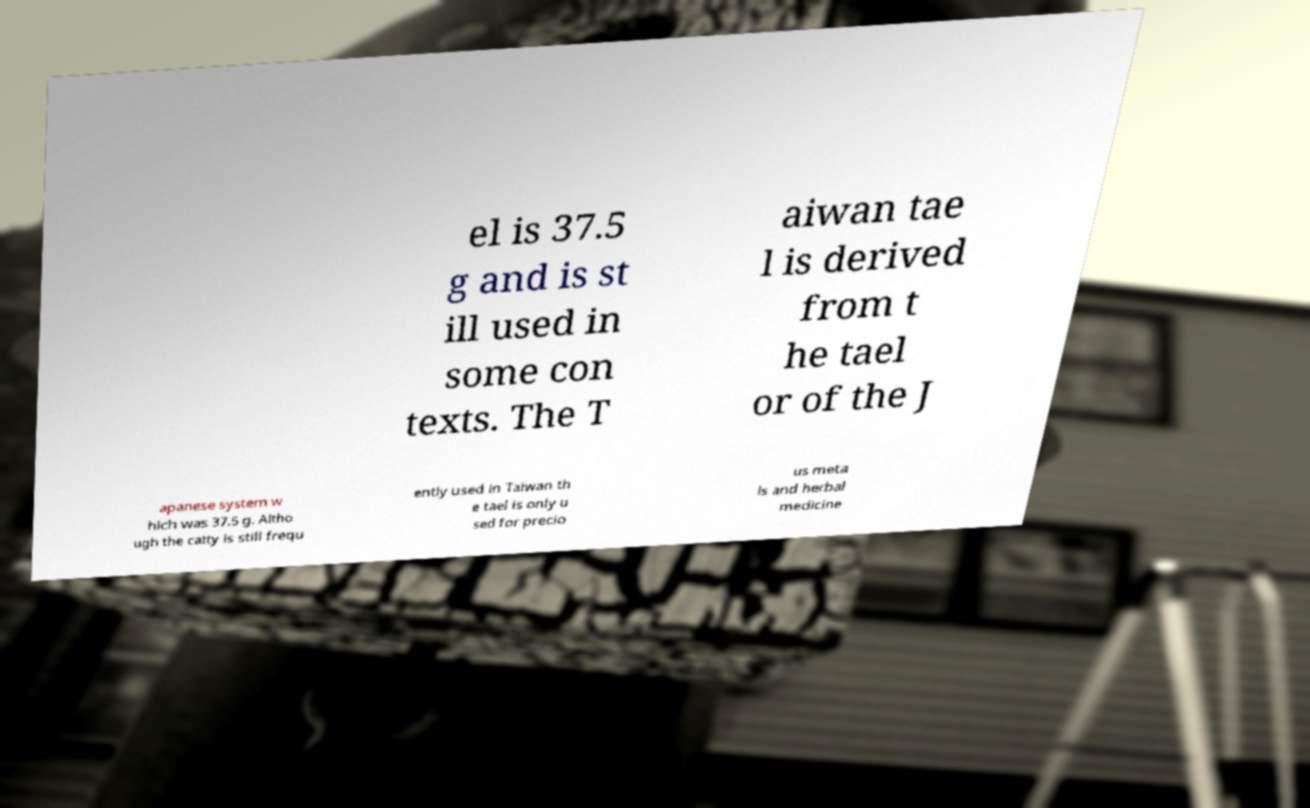For documentation purposes, I need the text within this image transcribed. Could you provide that? el is 37.5 g and is st ill used in some con texts. The T aiwan tae l is derived from t he tael or of the J apanese system w hich was 37.5 g. Altho ugh the catty is still frequ ently used in Taiwan th e tael is only u sed for precio us meta ls and herbal medicine 